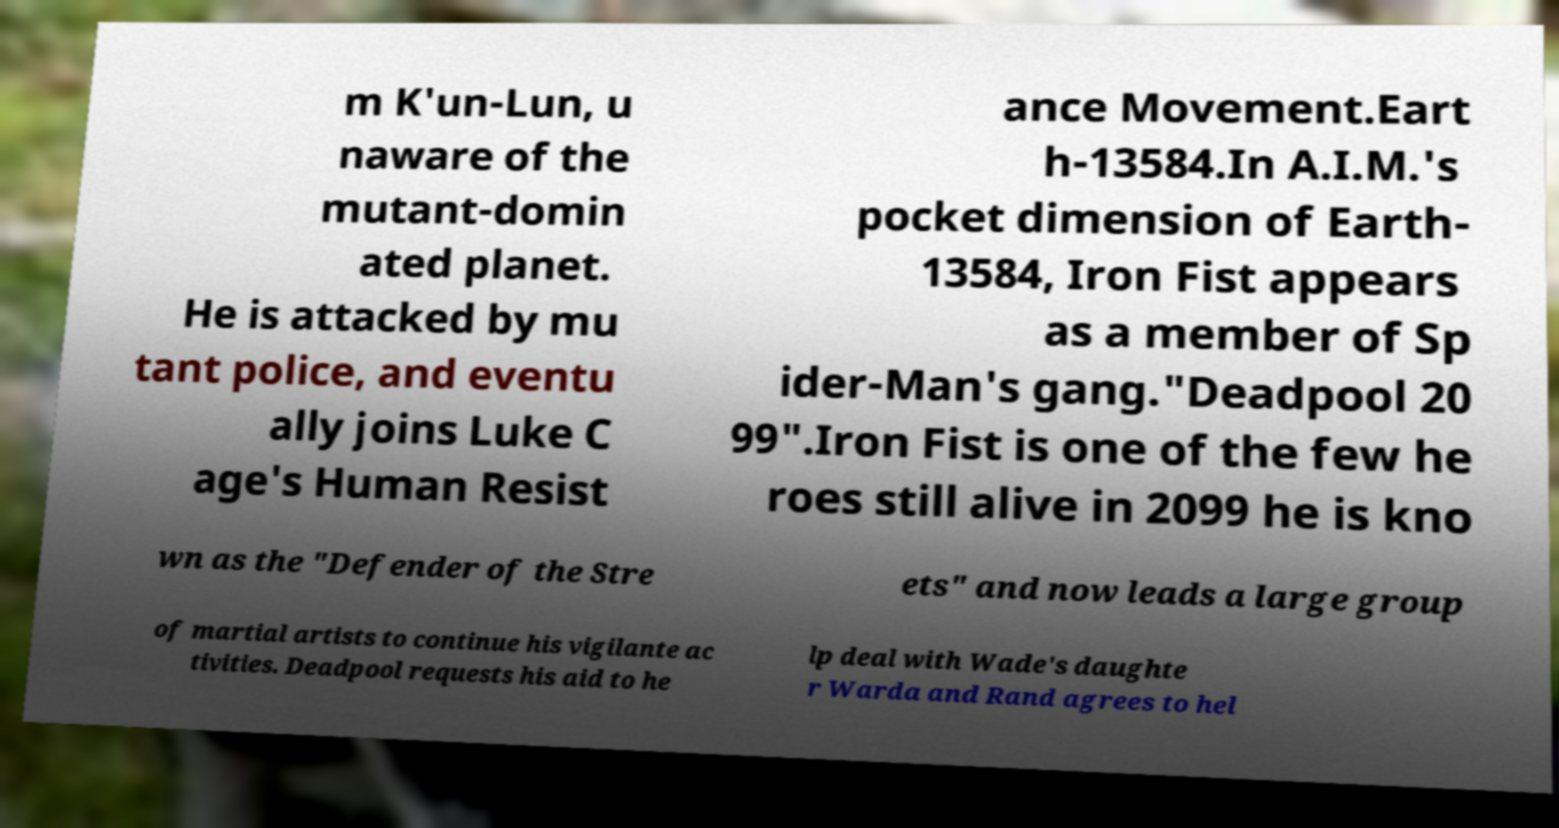What messages or text are displayed in this image? I need them in a readable, typed format. m K'un-Lun, u naware of the mutant-domin ated planet. He is attacked by mu tant police, and eventu ally joins Luke C age's Human Resist ance Movement.Eart h-13584.In A.I.M.'s pocket dimension of Earth- 13584, Iron Fist appears as a member of Sp ider-Man's gang."Deadpool 20 99".Iron Fist is one of the few he roes still alive in 2099 he is kno wn as the "Defender of the Stre ets" and now leads a large group of martial artists to continue his vigilante ac tivities. Deadpool requests his aid to he lp deal with Wade's daughte r Warda and Rand agrees to hel 